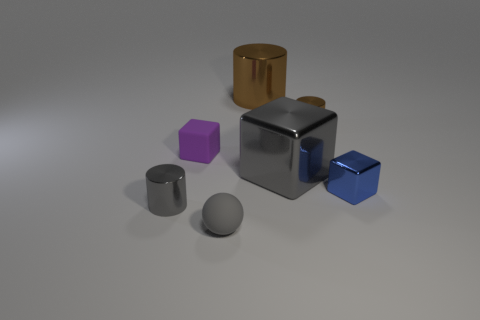Add 3 small gray metal objects. How many objects exist? 10 Subtract all cylinders. How many objects are left? 4 Subtract all blue objects. Subtract all purple cubes. How many objects are left? 5 Add 6 big shiny cubes. How many big shiny cubes are left? 7 Add 3 big blue rubber objects. How many big blue rubber objects exist? 3 Subtract 0 yellow cubes. How many objects are left? 7 